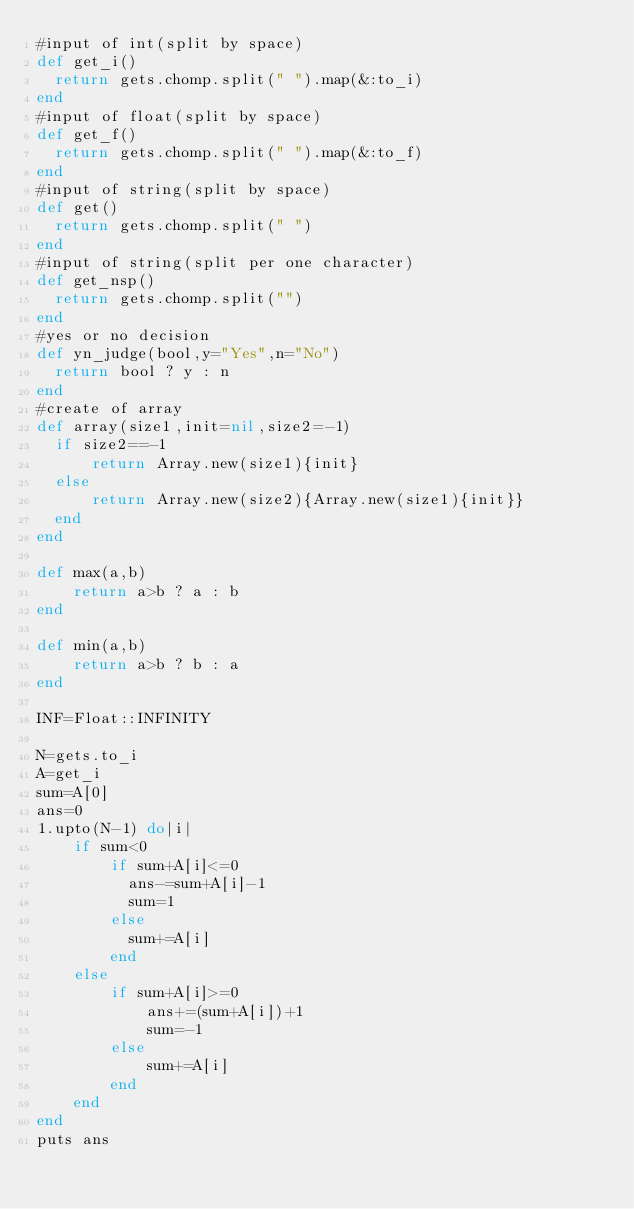<code> <loc_0><loc_0><loc_500><loc_500><_Ruby_>#input of int(split by space)
def get_i()
  return gets.chomp.split(" ").map(&:to_i)
end
#input of float(split by space)
def get_f()
  return gets.chomp.split(" ").map(&:to_f)
end
#input of string(split by space)
def get()
  return gets.chomp.split(" ")
end
#input of string(split per one character)
def get_nsp()
  return gets.chomp.split("")
end
#yes or no decision
def yn_judge(bool,y="Yes",n="No")
  return bool ? y : n 
end
#create of array
def array(size1,init=nil,size2=-1)
  if size2==-1
      return Array.new(size1){init}
  else
      return Array.new(size2){Array.new(size1){init}}
  end
end

def max(a,b)
    return a>b ? a : b
end

def min(a,b)
    return a>b ? b : a
end

INF=Float::INFINITY

N=gets.to_i
A=get_i
sum=A[0]
ans=0
1.upto(N-1) do|i|
    if sum<0
        if sum+A[i]<=0
          ans-=sum+A[i]-1
          sum=1
        else
          sum+=A[i]
        end
    else
        if sum+A[i]>=0
            ans+=(sum+A[i])+1
            sum=-1
        else
            sum+=A[i]
        end
    end
end
puts ans</code> 